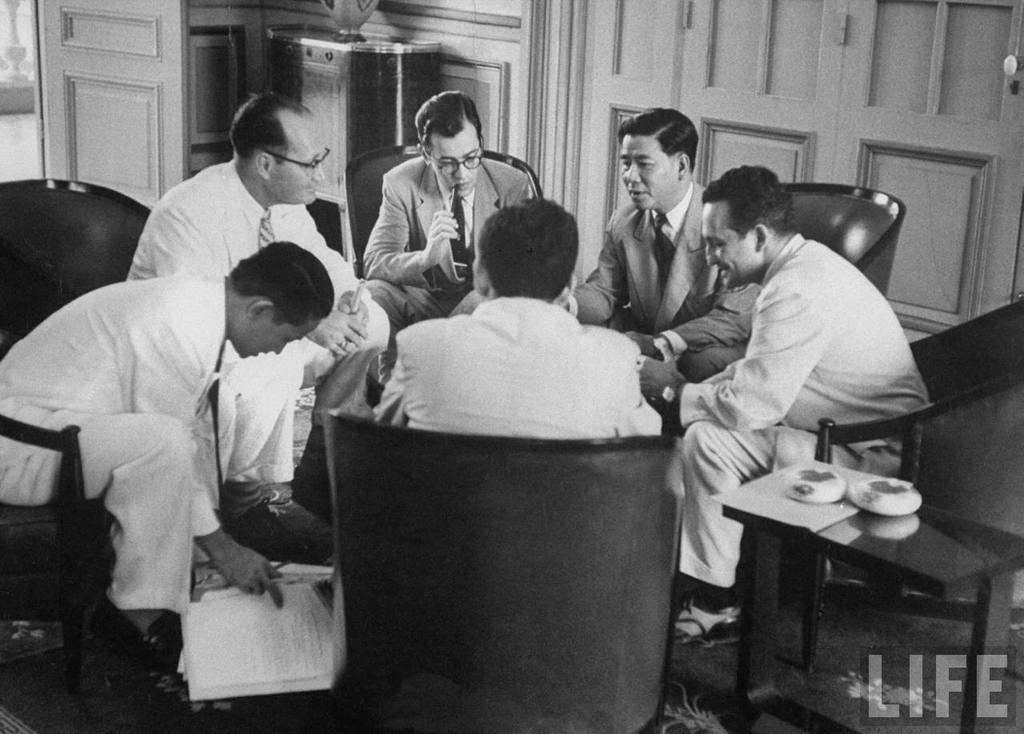What is the man in the image doing? The man is sitting on a chair in the image. Who is the man interacting with in the image? The man is talking to another person. What is the other person holding in their hand? The other person is holding papers in their hand. What can be seen in the background of the image? There are cupboards, a door, a vase, and pots in the background of the image. How many times does the man jump in the image? The man does not jump in the image; he is sitting on a chair. What type of step is visible in the background of the image? There is no step visible in the background of the image. 